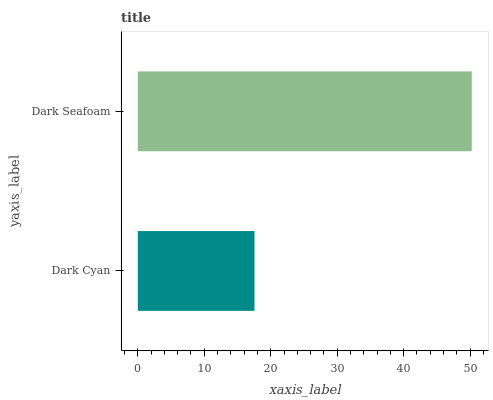Is Dark Cyan the minimum?
Answer yes or no. Yes. Is Dark Seafoam the maximum?
Answer yes or no. Yes. Is Dark Seafoam the minimum?
Answer yes or no. No. Is Dark Seafoam greater than Dark Cyan?
Answer yes or no. Yes. Is Dark Cyan less than Dark Seafoam?
Answer yes or no. Yes. Is Dark Cyan greater than Dark Seafoam?
Answer yes or no. No. Is Dark Seafoam less than Dark Cyan?
Answer yes or no. No. Is Dark Seafoam the high median?
Answer yes or no. Yes. Is Dark Cyan the low median?
Answer yes or no. Yes. Is Dark Cyan the high median?
Answer yes or no. No. Is Dark Seafoam the low median?
Answer yes or no. No. 